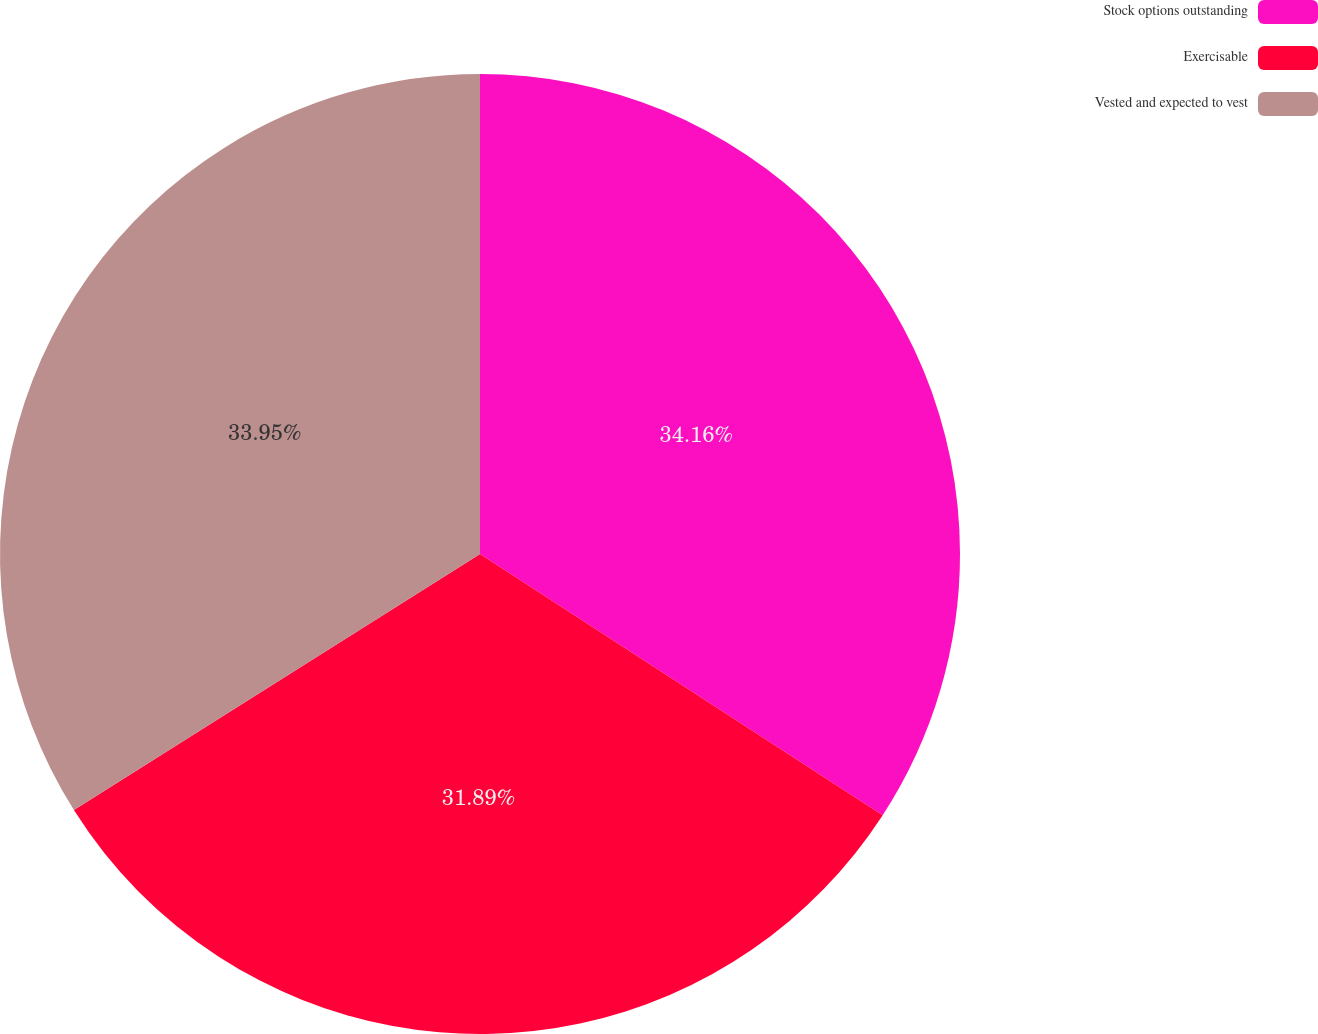Convert chart to OTSL. <chart><loc_0><loc_0><loc_500><loc_500><pie_chart><fcel>Stock options outstanding<fcel>Exercisable<fcel>Vested and expected to vest<nl><fcel>34.16%<fcel>31.89%<fcel>33.95%<nl></chart> 